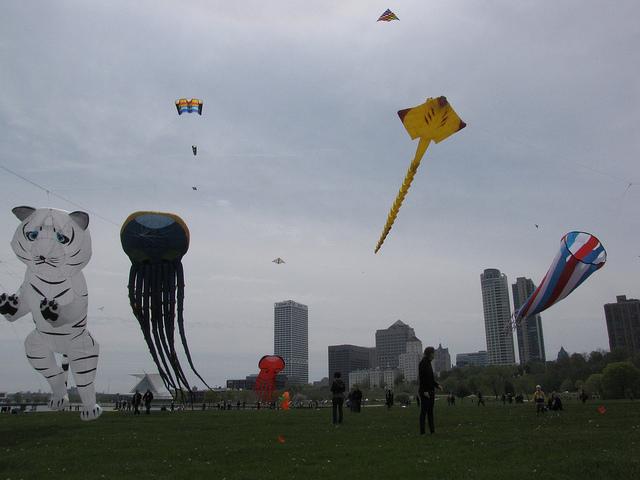Is this a rural festival?
Quick response, please. No. What animal is represented by the kite on the left?
Write a very short answer. Tiger. Are these kites elaborate?
Answer briefly. Yes. What are these people playing with?
Short answer required. Kites. Is it sunny?
Write a very short answer. No. 